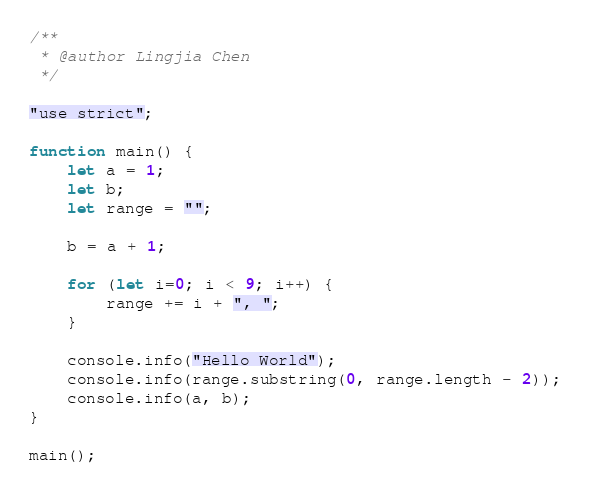Convert code to text. <code><loc_0><loc_0><loc_500><loc_500><_JavaScript_>/**
 * @author Lingjia Chen
 */

"use strict";

function main() {
    let a = 1;
    let b;
    let range = "";

    b = a + 1;

    for (let i=0; i < 9; i++) {
        range += i + ", ";
    }

    console.info("Hello World");
    console.info(range.substring(0, range.length - 2));
    console.info(a, b);
}

main();</code> 